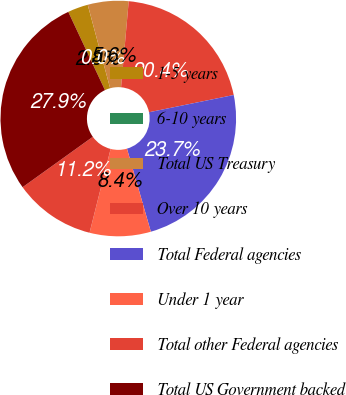Convert chart. <chart><loc_0><loc_0><loc_500><loc_500><pie_chart><fcel>1-5 years<fcel>6-10 years<fcel>Total US Treasury<fcel>Over 10 years<fcel>Total Federal agencies<fcel>Under 1 year<fcel>Total other Federal agencies<fcel>Total US Government backed<nl><fcel>2.8%<fcel>0.0%<fcel>5.59%<fcel>20.39%<fcel>23.74%<fcel>8.38%<fcel>11.17%<fcel>27.93%<nl></chart> 